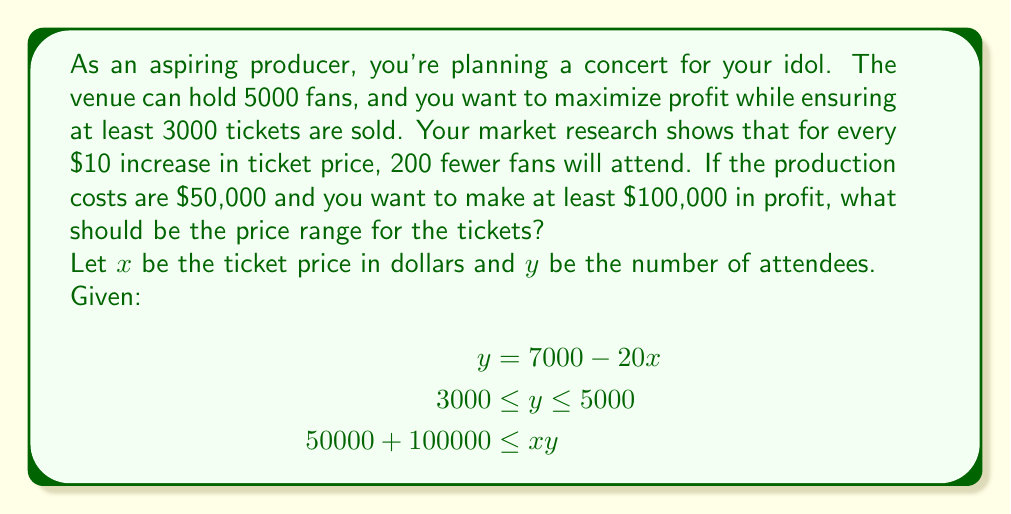Provide a solution to this math problem. To solve this problem, we'll follow these steps:

1) First, let's consider the attendance constraint:
   $$3000 \leq y \leq 5000$$
   
   Substituting $y = 7000 - 20x$:
   $$3000 \leq 7000 - 20x \leq 5000$$

2) Solve the left inequality:
   $$3000 \leq 7000 - 20x$$
   $$-4000 \leq -20x$$
   $$200 \geq x$$

3) Solve the right inequality:
   $$7000 - 20x \leq 5000$$
   $$-20x \leq -2000$$
   $$x \geq 100$$

4) Now, consider the profit constraint:
   $$50000 + 100000 \leq xy$$
   $$150000 \leq xy$$

   Substitute $y = 7000 - 20x$:
   $$150000 \leq x(7000 - 20x)$$
   $$150000 \leq 7000x - 20x^2$$

5) Solve this quadratic inequality:
   $$20x^2 - 7000x + 150000 \leq 0$$
   
   The roots of this quadratic are approximately 75 and 275.
   The inequality is satisfied when $75 \leq x \leq 275$.

6) Combining all constraints:
   $$100 \leq x \leq 200$$

Therefore, the optimal price range is between $100 and $200.
Answer: $100 \leq x \leq 200$, where $x$ is the ticket price in dollars. 